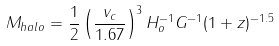<formula> <loc_0><loc_0><loc_500><loc_500>M _ { h a l o } = \frac { 1 } { 2 } \left ( \frac { v _ { c } } { 1 . 6 7 } \right ) ^ { 3 } H _ { o } ^ { - 1 } G ^ { - 1 } ( 1 + z ) ^ { - 1 . 5 }</formula> 